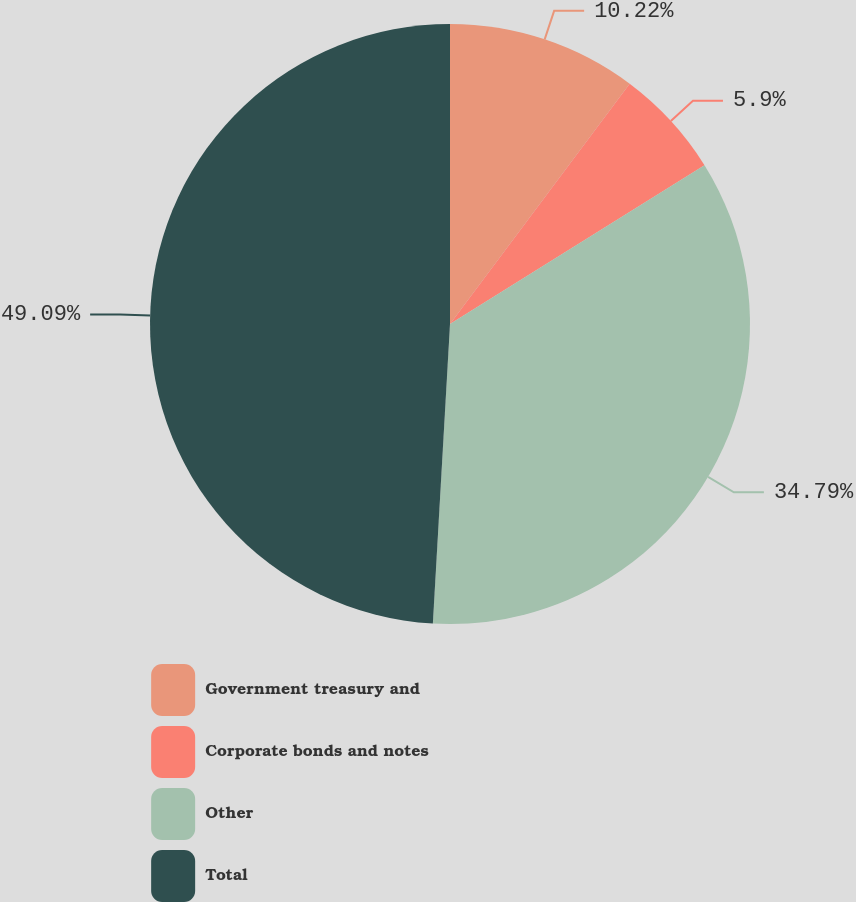<chart> <loc_0><loc_0><loc_500><loc_500><pie_chart><fcel>Government treasury and<fcel>Corporate bonds and notes<fcel>Other<fcel>Total<nl><fcel>10.22%<fcel>5.9%<fcel>34.79%<fcel>49.09%<nl></chart> 